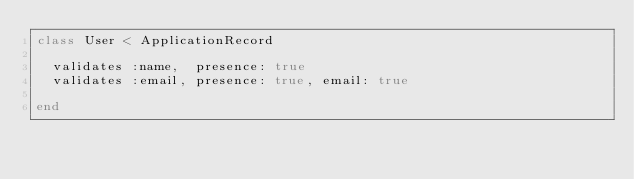Convert code to text. <code><loc_0><loc_0><loc_500><loc_500><_Ruby_>class User < ApplicationRecord

  validates :name,  presence: true
  validates :email, presence: true, email: true

end
</code> 